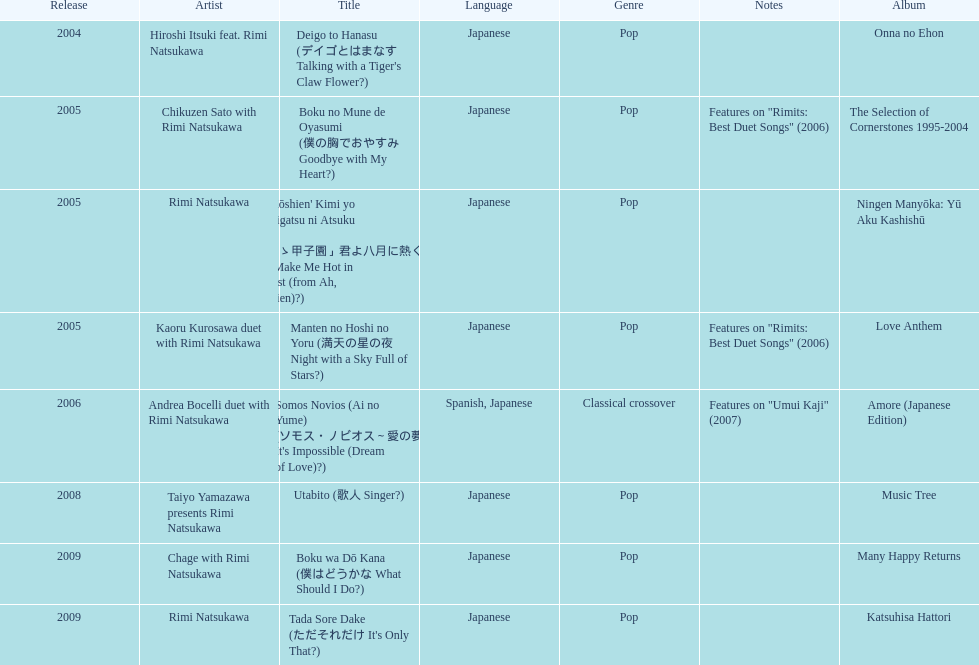What has been the last song this artist has made an other appearance on? Tada Sore Dake. 